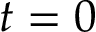<formula> <loc_0><loc_0><loc_500><loc_500>t = 0</formula> 